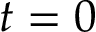<formula> <loc_0><loc_0><loc_500><loc_500>t = 0</formula> 